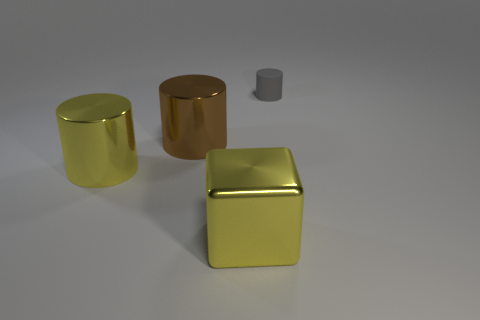There is a large shiny object that is behind the yellow metallic thing behind the big metal object in front of the yellow cylinder; what is its color? The large shiny object in question appears to be a silvery-gray color. This can be deduced by observing the light reflections and the inherent properties of the surface, which suggest a metallic finish typical of objects like steel or aluminum. 